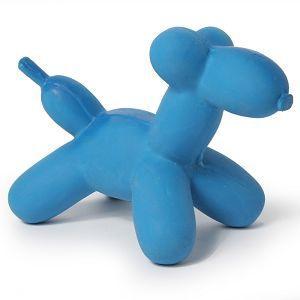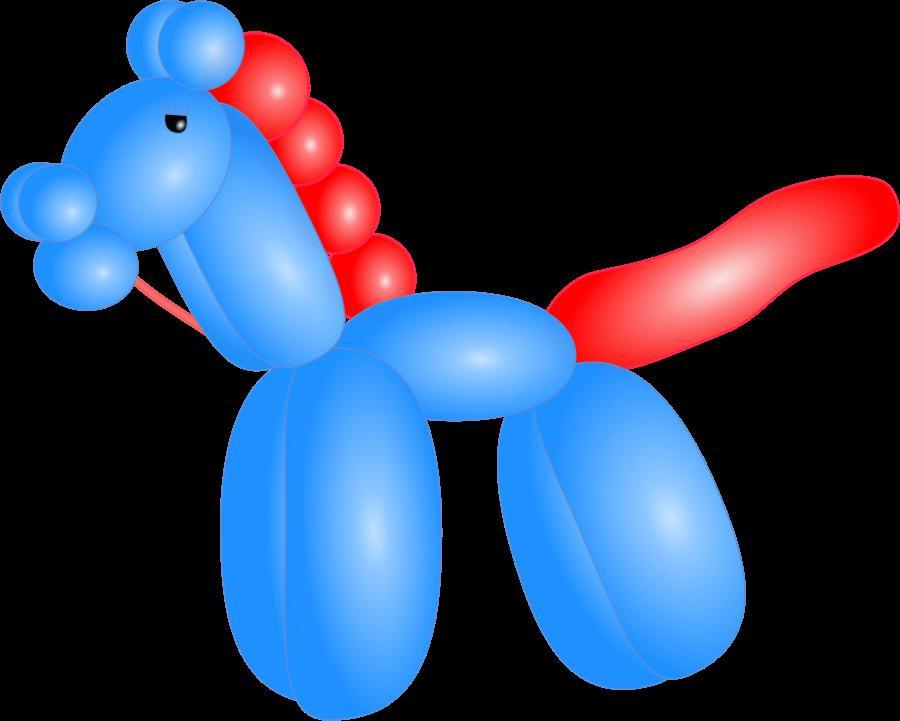The first image is the image on the left, the second image is the image on the right. Examine the images to the left and right. Is the description "Only animal-shaped balloon animals are shown." accurate? Answer yes or no. Yes. 